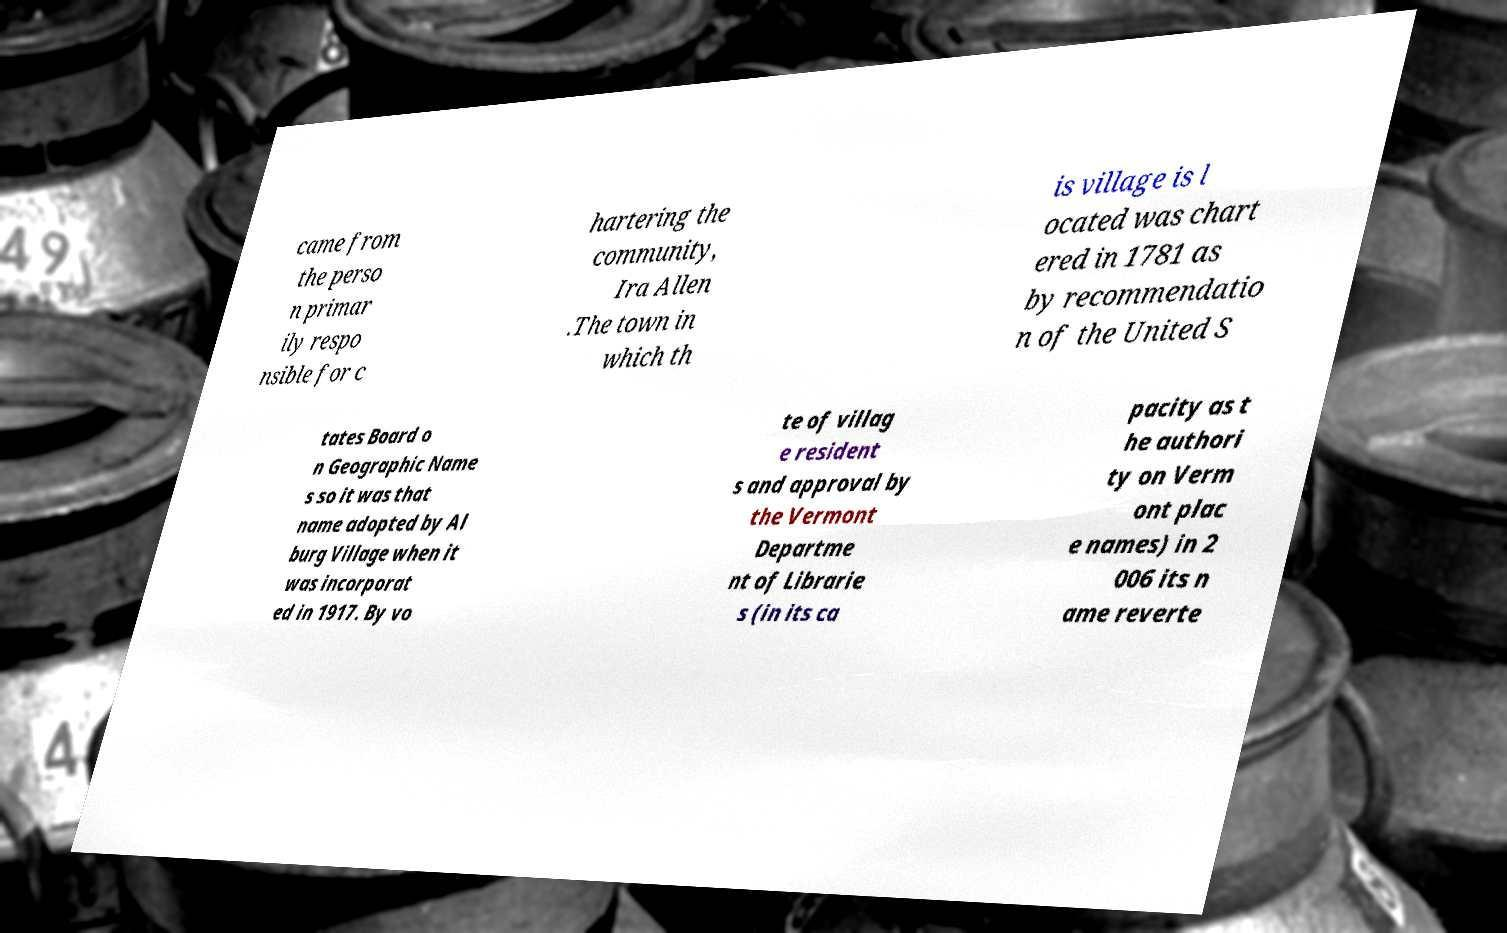Can you accurately transcribe the text from the provided image for me? came from the perso n primar ily respo nsible for c hartering the community, Ira Allen .The town in which th is village is l ocated was chart ered in 1781 as by recommendatio n of the United S tates Board o n Geographic Name s so it was that name adopted by Al burg Village when it was incorporat ed in 1917. By vo te of villag e resident s and approval by the Vermont Departme nt of Librarie s (in its ca pacity as t he authori ty on Verm ont plac e names) in 2 006 its n ame reverte 